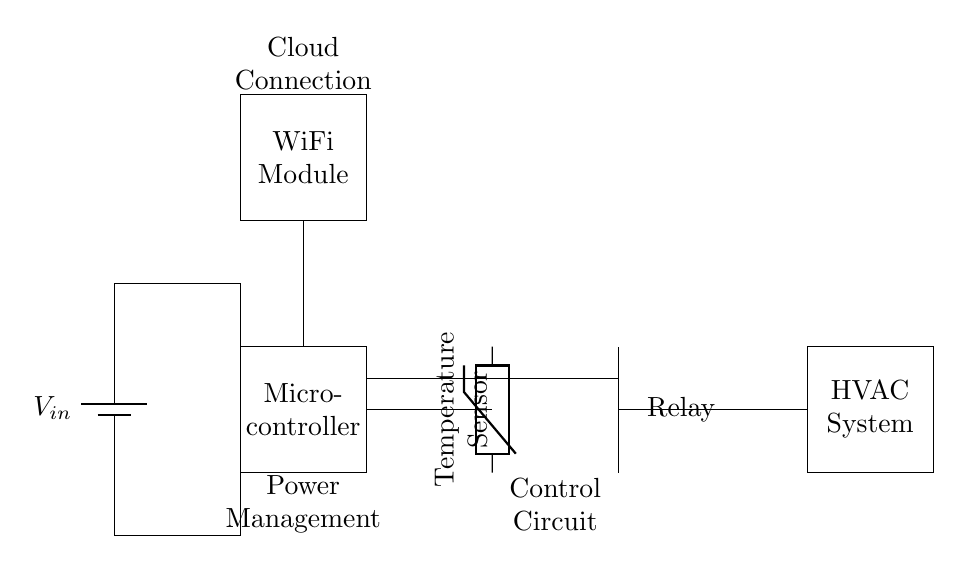What is the main power source for this circuit? The circuit is powered by a battery, labeled as V_in, which indicates it is the primary source of energy.
Answer: Battery What component measures the temperature? The temperature sensor, depicted as a thermistor in the circuit, is responsible for measuring the temperature.
Answer: Temperature sensor How does the microcontroller receive temperature data? The microcontroller receives temperature data through connections from the temperature sensor, which is wired directly to it, enabling data processing.
Answer: Direct connection What is the function of the relay in this circuit? The relay acts as a switch to control the HVAC system based on the temperature data processed by the microcontroller.
Answer: Control HVAC How many components are used for power management in this circuit? There are two components involved in power management: the battery and the power connections that distribute voltage to other parts of the circuit.
Answer: Two components What component allows this circuit to connect to cloud services? The WiFi module facilitates cloud connection, enabling communication with external services, like data storage or remote monitoring.
Answer: WiFi module What type of circuit is this specifically designed for? This circuit is tailored for optimizing energy consumption in storage facilities by controlling HVAC systems based on temperature readings.
Answer: Energy optimization 